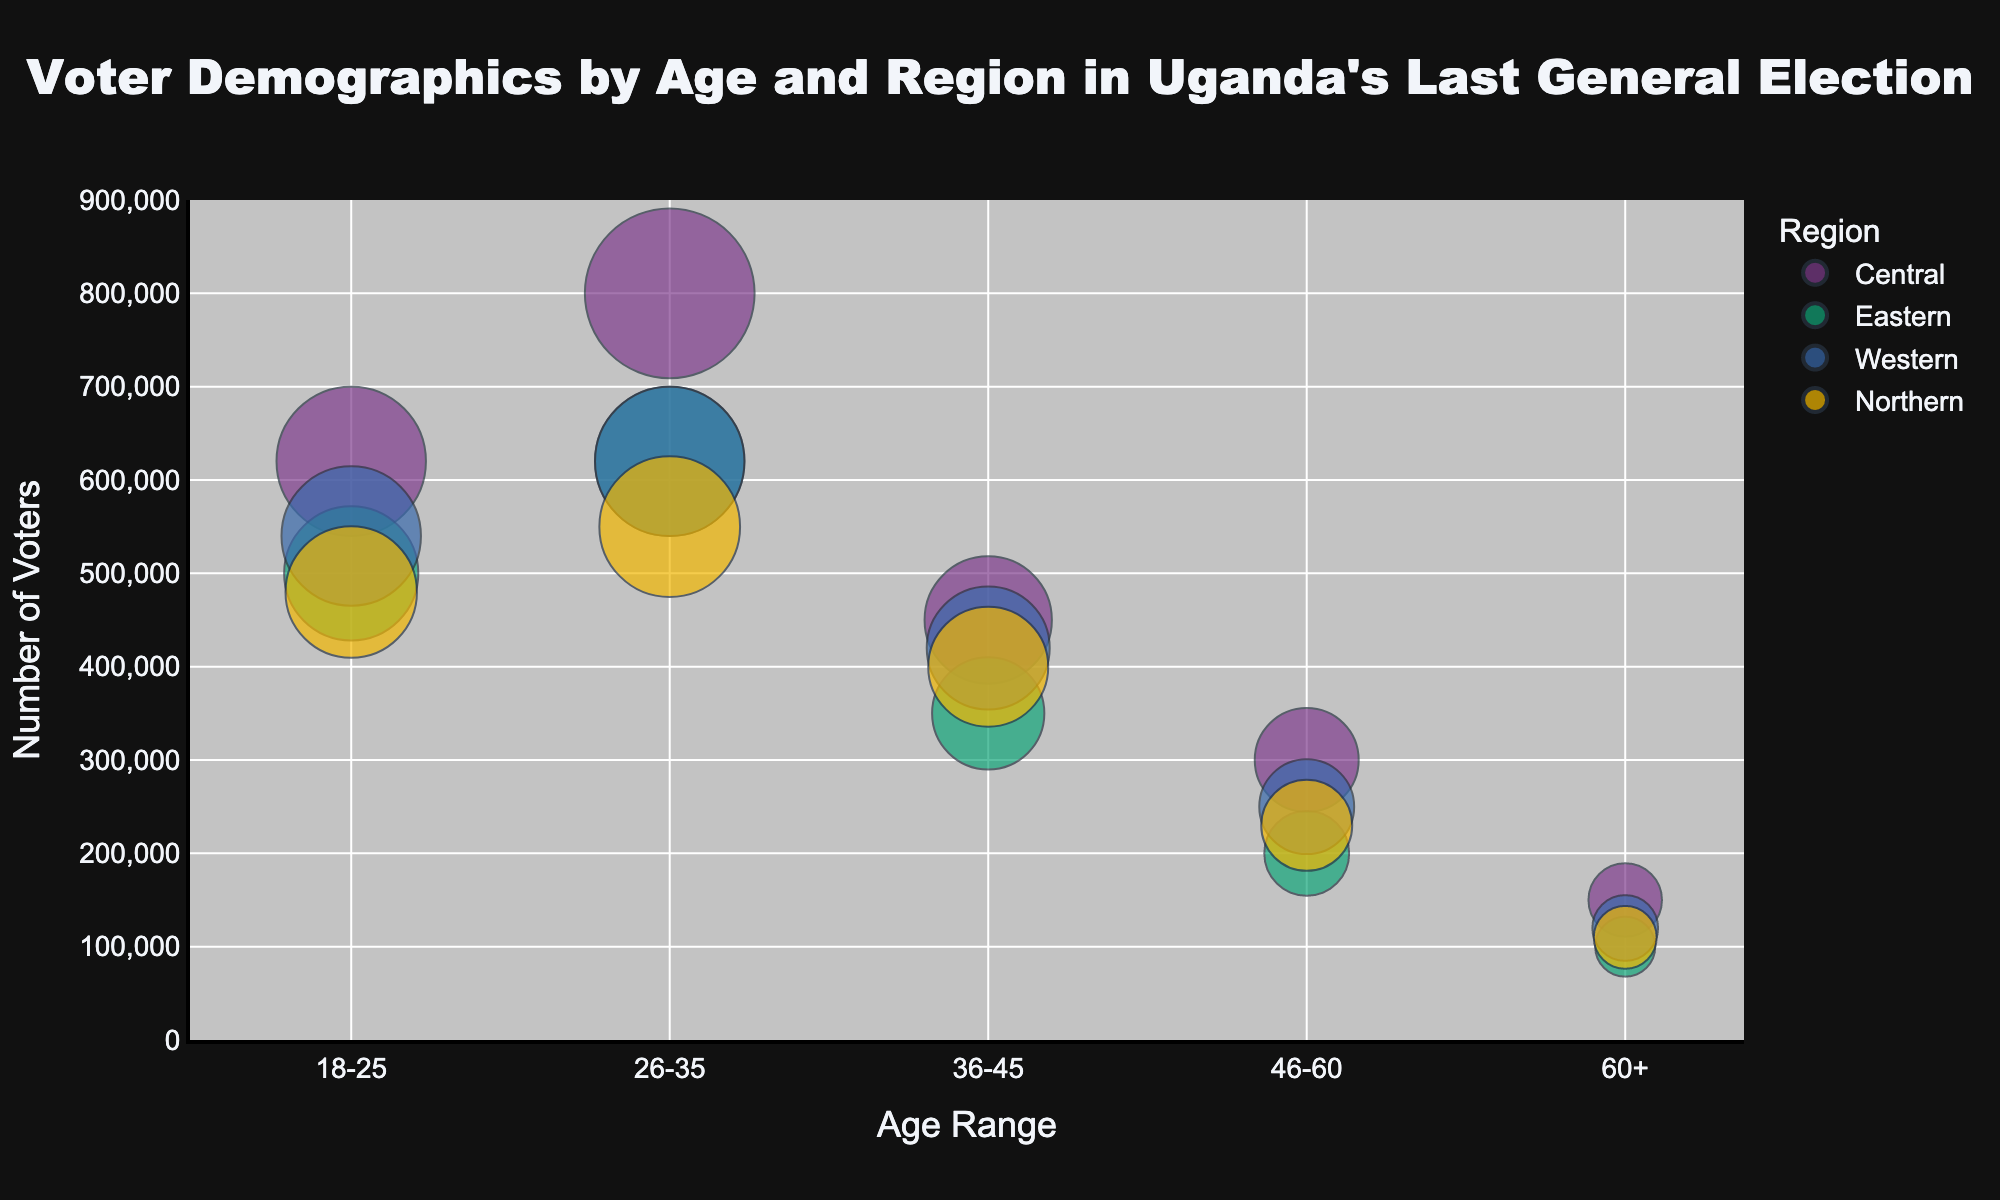What is the title of the chart? The title is displayed prominently at the top of the chart. It reads "Voter Demographics by Age and Region in Uganda's Last General Election."
Answer: Voter Demographics by Age and Region in Uganda's Last General Election How many age ranges are represented in the chart? The x-axis lists the age ranges as defined in the dataset: 18-25, 26-35, 36-45, 46-60, and 60+. Counting these categories, we have a total of 5 age ranges.
Answer: 5 Which region had the highest number of voters in the 26-35 age range? By examining the bubbles in the chart for the 26-35 age range on the x-axis, we see that the largest bubble (representing the highest number of voters) corresponds to the Central region with 800,000 voters.
Answer: Central What is the combined number of voters for the 36-45 and 46-60 age ranges in the Northern region? From the chart, the number of voters in the Northern region are 400,000 for the 36-45 age range and 230,000 for the 46-60 age range. Adding these together, 400,000 + 230,000 gives 630,000.
Answer: 630,000 Which age range had the smallest number of voters in the Western region? By scanning the bubbles for the Western region across all age ranges, we see that the smallest bubble is for the 60+ age range with 120,000 voters.
Answer: 60+ In the Eastern region, how does the number of voters aged 18-25 compare to those aged 60+? Comparing the bubbles in the Eastern region for the 18-25 age range (500,000 voters) and the 60+ age range (100,000 voters), we can see that there are 400,000 more voters in the 18-25 age range compared to the 60+ age range.
Answer: 400,000 more What is the difference in the number of voters between the 26-35 and 36-45 age ranges in the Central region? In the Central region, the number of voters for the 26-35 age range is 800,000 and for the 36-45 age range is 450,000. The difference is 800,000 - 450,000, which equals 350,000.
Answer: 350,000 Which region has the largest bubble in the 18-25 age range? By inspecting the bubbles in the 18-25 age range across all regions, the Central region has the largest bubble with 620,000 voters.
Answer: Central Among the 4 regions, which has the lowest number of voters across all age ranges? Summarizing the number of voters from the chart for all age ranges by region: Northern (1,770,000), Western (1,950,000), Eastern (1,770,000), and Central (2,320,000). Both the Northern and Eastern regions have the lowest cumulative total with 1,770,000 voters each.
Answer: Northern and Eastern 